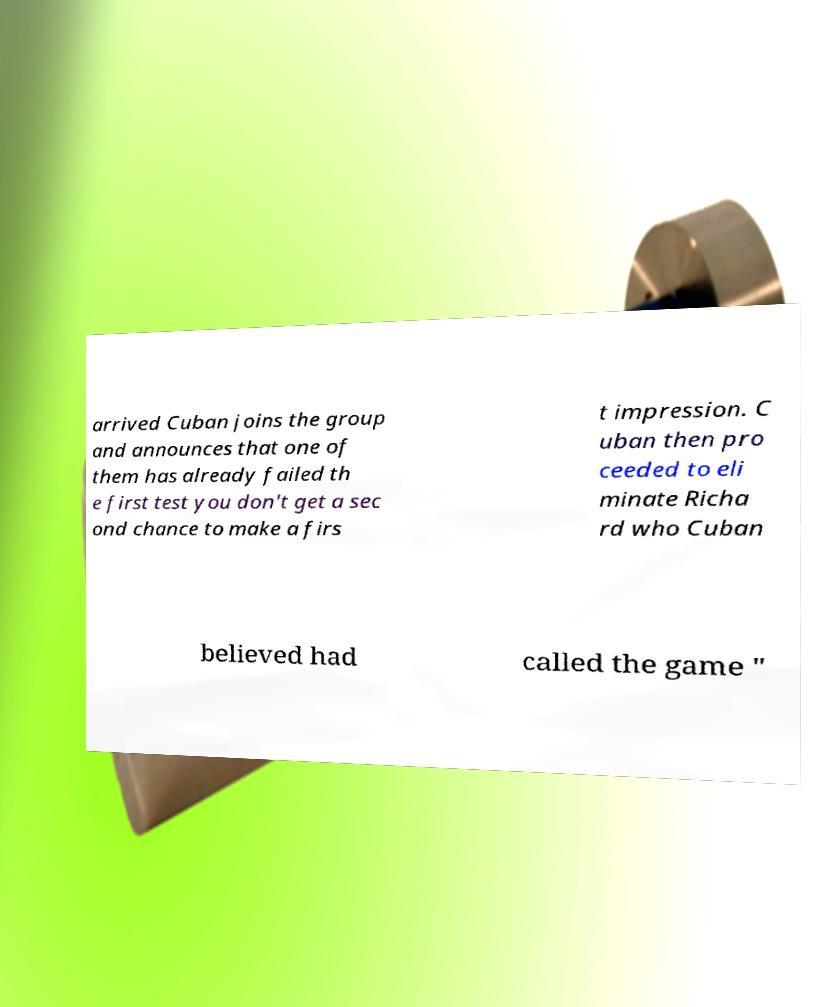Can you read and provide the text displayed in the image?This photo seems to have some interesting text. Can you extract and type it out for me? arrived Cuban joins the group and announces that one of them has already failed th e first test you don't get a sec ond chance to make a firs t impression. C uban then pro ceeded to eli minate Richa rd who Cuban believed had called the game " 